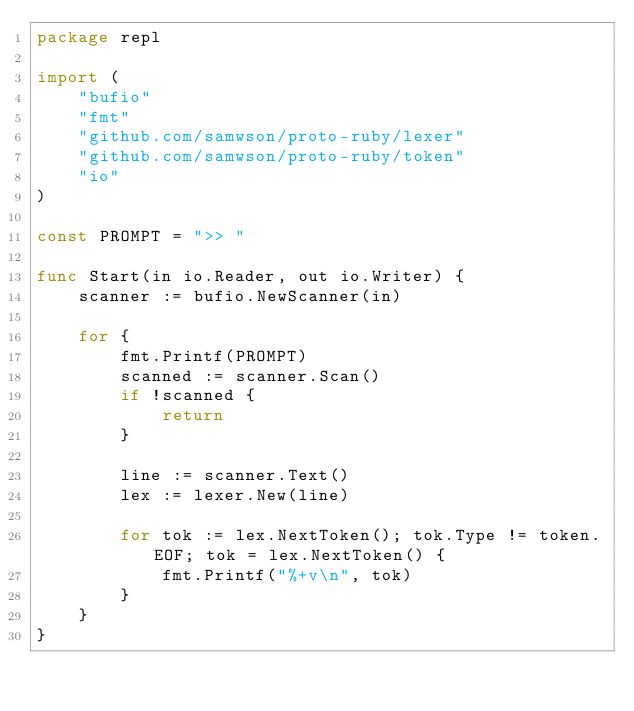Convert code to text. <code><loc_0><loc_0><loc_500><loc_500><_Go_>package repl

import (
	"bufio"
	"fmt"
	"github.com/samwson/proto-ruby/lexer"
	"github.com/samwson/proto-ruby/token"
	"io"
)

const PROMPT = ">> "

func Start(in io.Reader, out io.Writer) {
	scanner := bufio.NewScanner(in)

	for {
		fmt.Printf(PROMPT)
		scanned := scanner.Scan()
		if !scanned {
			return
		}

		line := scanner.Text()
		lex := lexer.New(line)

		for tok := lex.NextToken(); tok.Type != token.EOF; tok = lex.NextToken() {
			fmt.Printf("%+v\n", tok)
		}
	}
}
</code> 